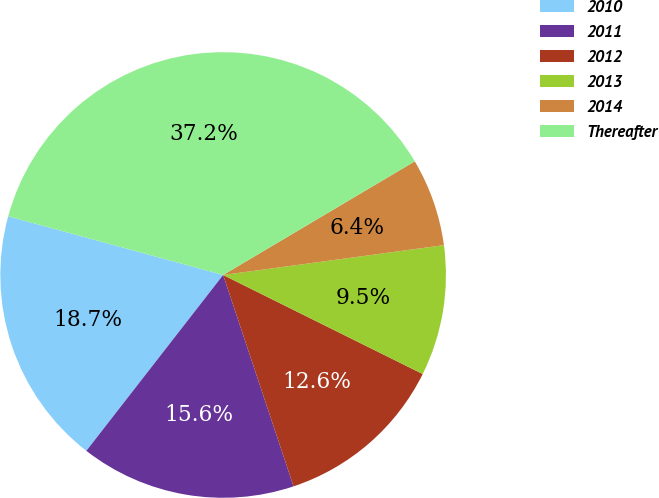Convert chart. <chart><loc_0><loc_0><loc_500><loc_500><pie_chart><fcel>2010<fcel>2011<fcel>2012<fcel>2013<fcel>2014<fcel>Thereafter<nl><fcel>18.72%<fcel>15.64%<fcel>12.55%<fcel>9.47%<fcel>6.38%<fcel>37.24%<nl></chart> 